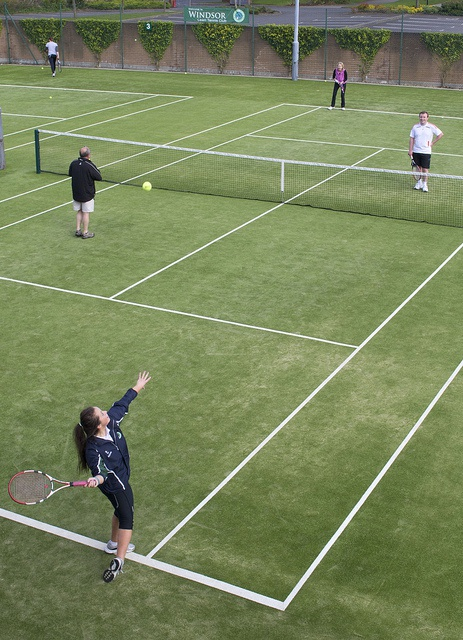Describe the objects in this image and their specific colors. I can see people in olive, black, navy, gray, and lightpink tones, people in olive, black, darkgray, gray, and lightgray tones, people in olive, lavender, black, and darkgray tones, tennis racket in olive and gray tones, and people in olive, black, and gray tones in this image. 